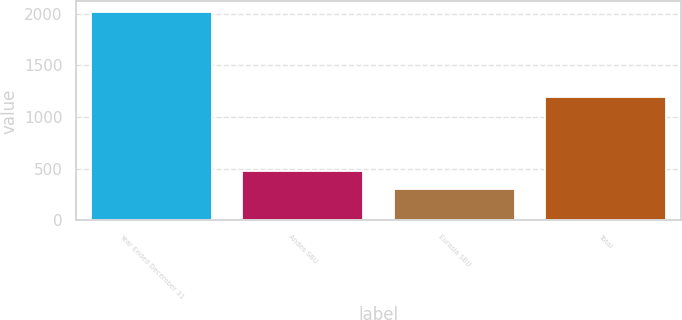Convert chart to OTSL. <chart><loc_0><loc_0><loc_500><loc_500><bar_chart><fcel>Year Ended December 31<fcel>Andes SBU<fcel>Eurasia SBU<fcel>Total<nl><fcel>2017<fcel>478<fcel>307<fcel>1197<nl></chart> 